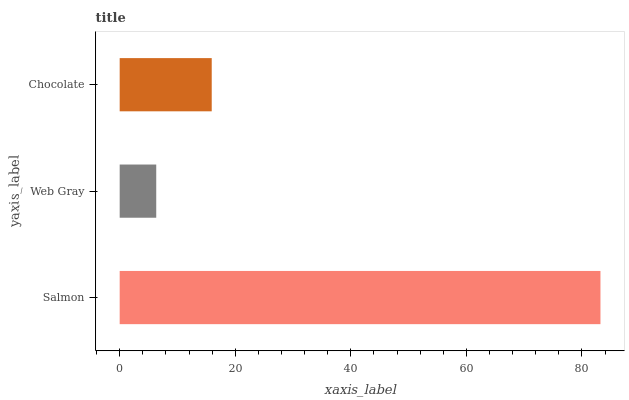Is Web Gray the minimum?
Answer yes or no. Yes. Is Salmon the maximum?
Answer yes or no. Yes. Is Chocolate the minimum?
Answer yes or no. No. Is Chocolate the maximum?
Answer yes or no. No. Is Chocolate greater than Web Gray?
Answer yes or no. Yes. Is Web Gray less than Chocolate?
Answer yes or no. Yes. Is Web Gray greater than Chocolate?
Answer yes or no. No. Is Chocolate less than Web Gray?
Answer yes or no. No. Is Chocolate the high median?
Answer yes or no. Yes. Is Chocolate the low median?
Answer yes or no. Yes. Is Web Gray the high median?
Answer yes or no. No. Is Salmon the low median?
Answer yes or no. No. 